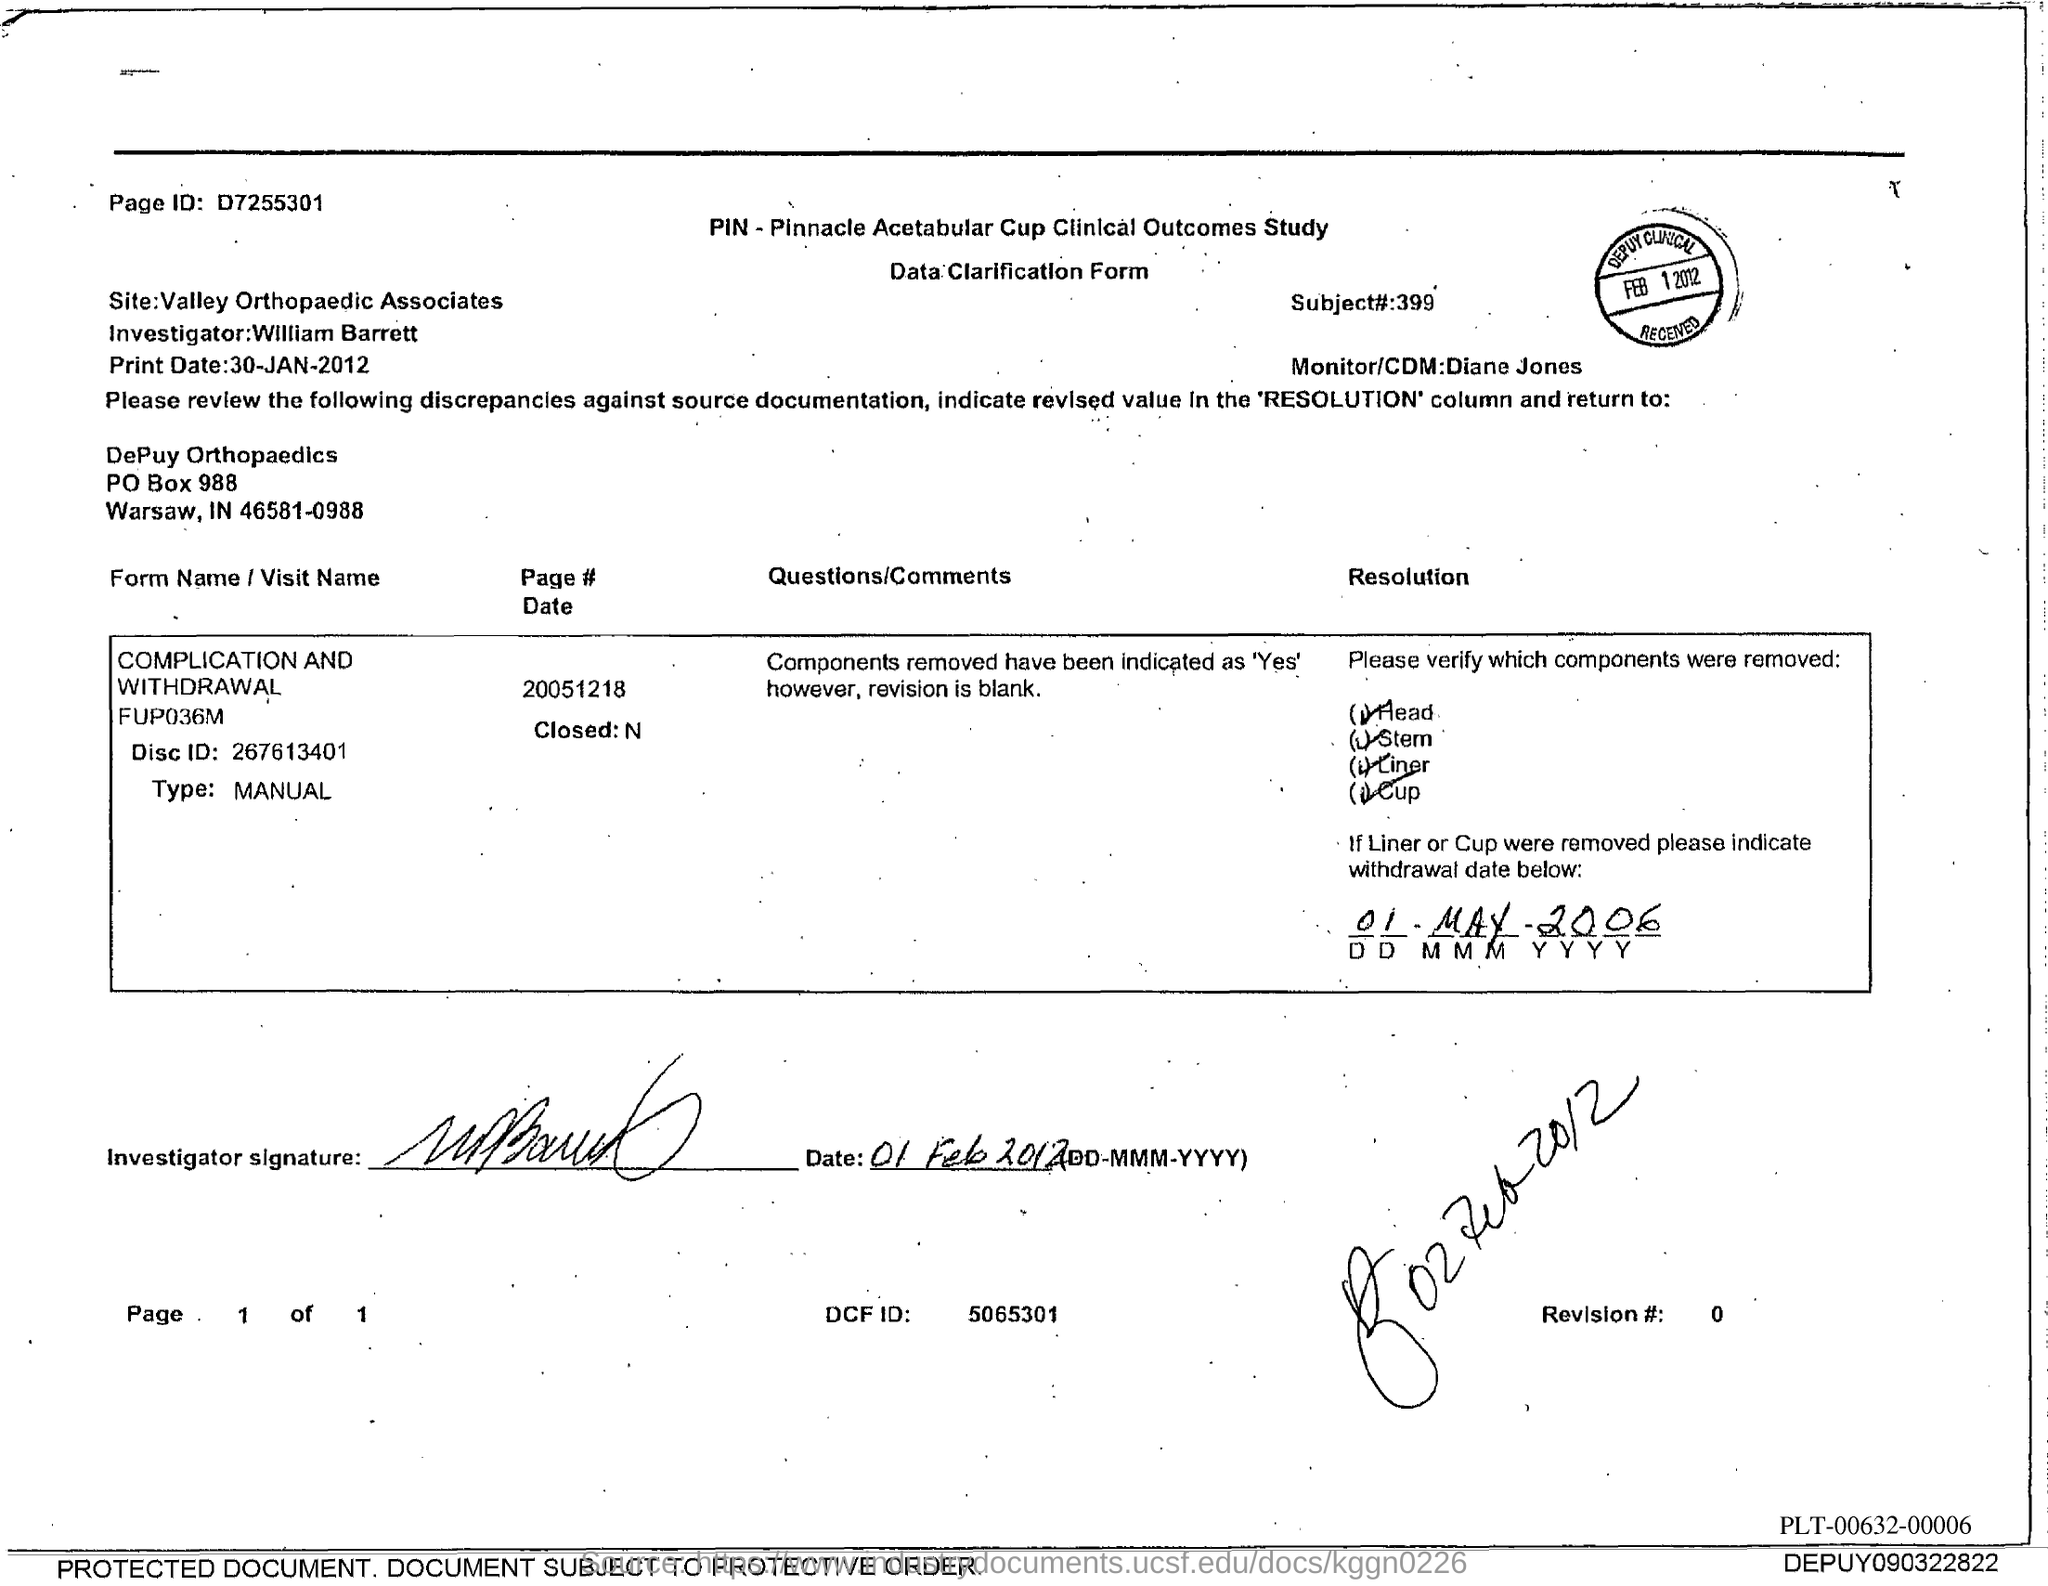Identify some key points in this picture. William Barrett is the investigator. The PO Box number mentioned in the document is 988. The Monitor/CDM is Diane Jones. The page identifier is D7255301. The disc ID is 267613401. 